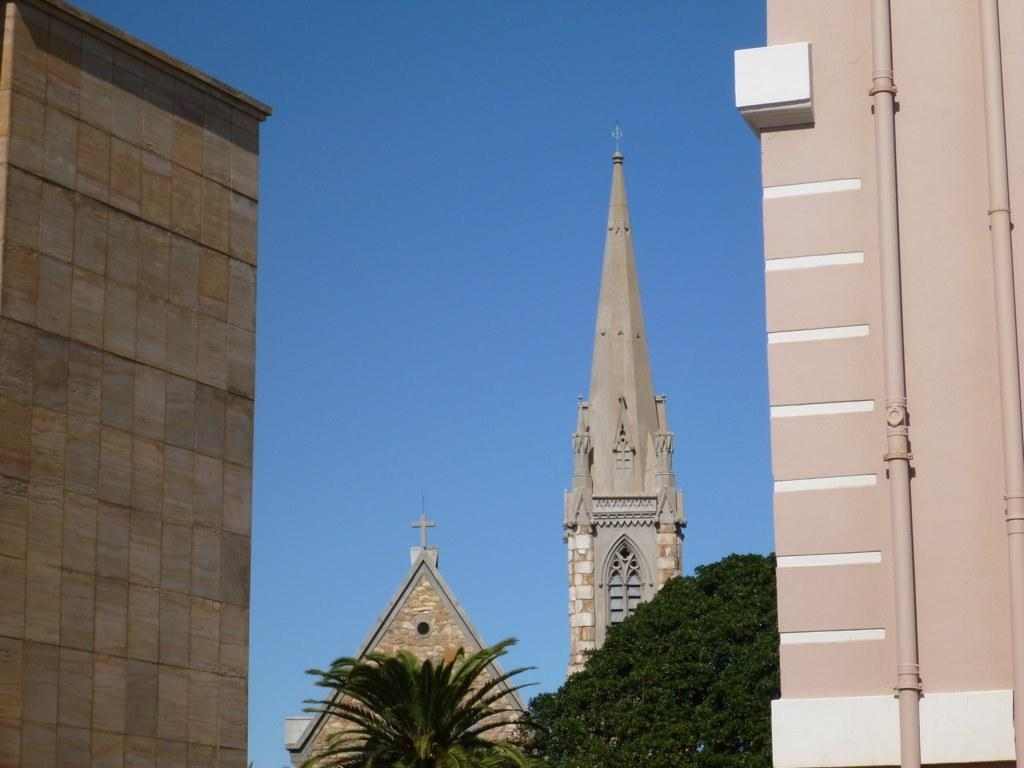What type of structures can be seen in the image? A: There are pipes and walls visible in the image. What else can be seen in the image besides structures? There are trees and the top view of buildings visible in the image. What is visible in the background of the image? The sky is visible in the background of the image. What type of hobbies can be seen being practiced by the trees in the image? There are no hobbies being practiced by the trees in the image, as trees do not have hobbies. What color is the thumb of the person in the image? There is no person present in the image, so it is not possible to determine the color of their thumb. 